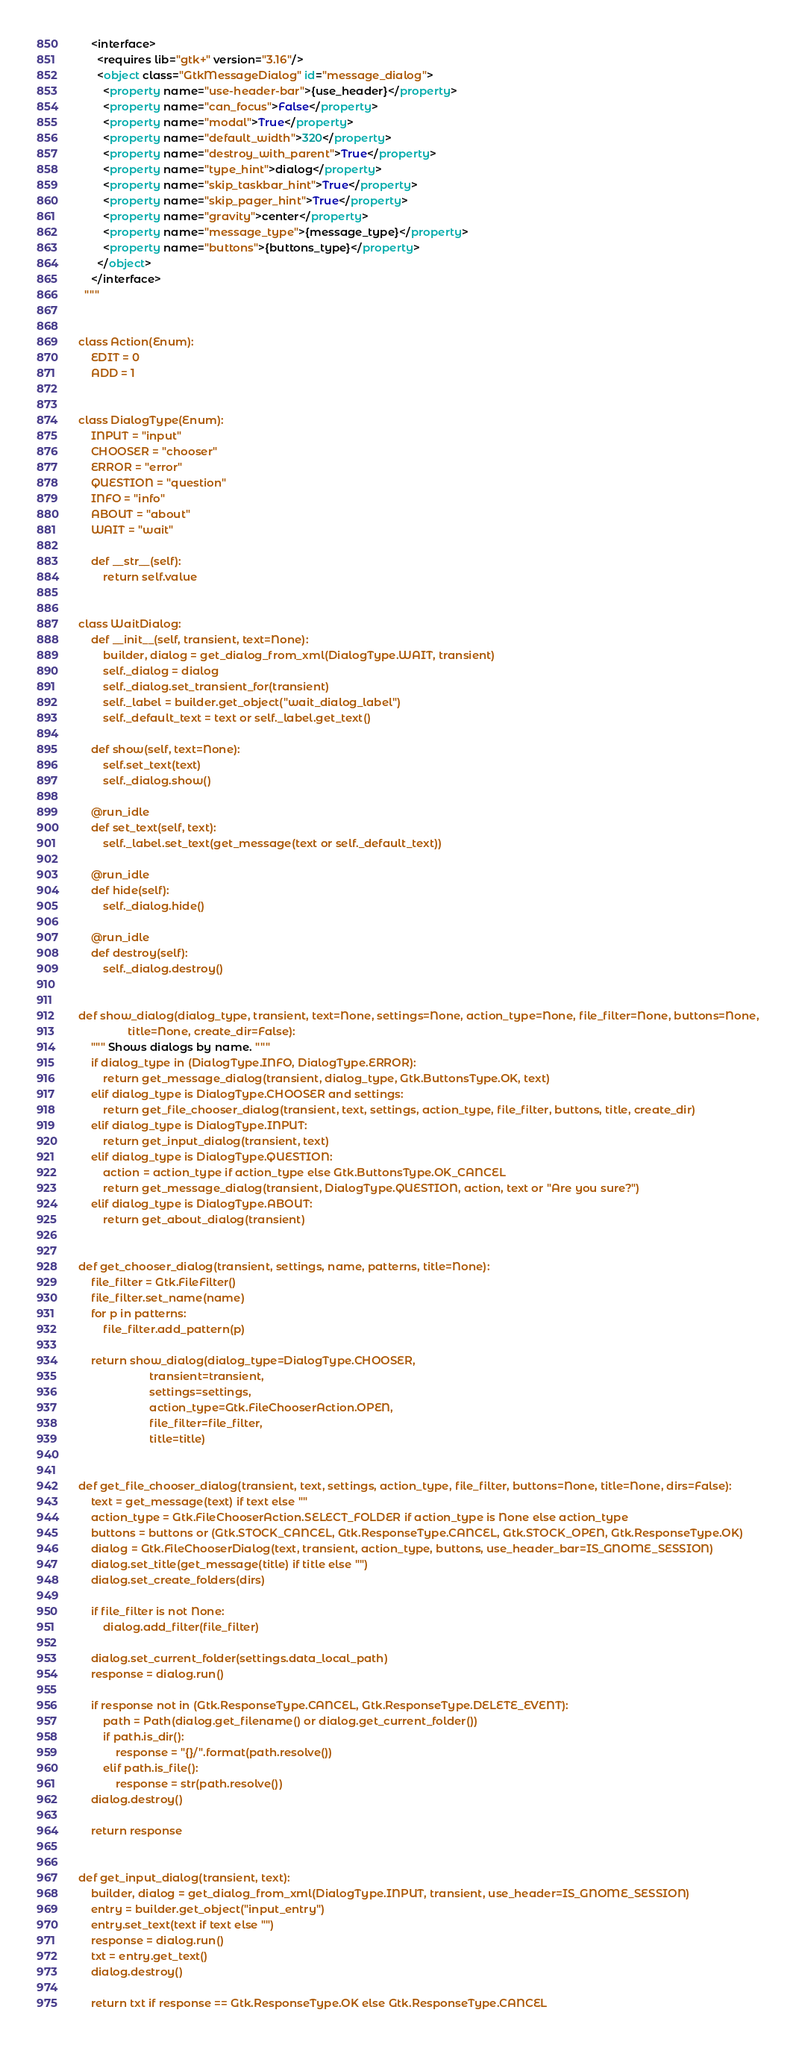Convert code to text. <code><loc_0><loc_0><loc_500><loc_500><_Python_>    <interface>
      <requires lib="gtk+" version="3.16"/>
      <object class="GtkMessageDialog" id="message_dialog">
        <property name="use-header-bar">{use_header}</property>
        <property name="can_focus">False</property>
        <property name="modal">True</property>
        <property name="default_width">320</property>
        <property name="destroy_with_parent">True</property>
        <property name="type_hint">dialog</property>
        <property name="skip_taskbar_hint">True</property>
        <property name="skip_pager_hint">True</property>
        <property name="gravity">center</property>
        <property name="message_type">{message_type}</property>
        <property name="buttons">{buttons_type}</property>
      </object>
    </interface>
  """


class Action(Enum):
    EDIT = 0
    ADD = 1


class DialogType(Enum):
    INPUT = "input"
    CHOOSER = "chooser"
    ERROR = "error"
    QUESTION = "question"
    INFO = "info"
    ABOUT = "about"
    WAIT = "wait"

    def __str__(self):
        return self.value


class WaitDialog:
    def __init__(self, transient, text=None):
        builder, dialog = get_dialog_from_xml(DialogType.WAIT, transient)
        self._dialog = dialog
        self._dialog.set_transient_for(transient)
        self._label = builder.get_object("wait_dialog_label")
        self._default_text = text or self._label.get_text()

    def show(self, text=None):
        self.set_text(text)
        self._dialog.show()

    @run_idle
    def set_text(self, text):
        self._label.set_text(get_message(text or self._default_text))

    @run_idle
    def hide(self):
        self._dialog.hide()

    @run_idle
    def destroy(self):
        self._dialog.destroy()


def show_dialog(dialog_type, transient, text=None, settings=None, action_type=None, file_filter=None, buttons=None,
                title=None, create_dir=False):
    """ Shows dialogs by name. """
    if dialog_type in (DialogType.INFO, DialogType.ERROR):
        return get_message_dialog(transient, dialog_type, Gtk.ButtonsType.OK, text)
    elif dialog_type is DialogType.CHOOSER and settings:
        return get_file_chooser_dialog(transient, text, settings, action_type, file_filter, buttons, title, create_dir)
    elif dialog_type is DialogType.INPUT:
        return get_input_dialog(transient, text)
    elif dialog_type is DialogType.QUESTION:
        action = action_type if action_type else Gtk.ButtonsType.OK_CANCEL
        return get_message_dialog(transient, DialogType.QUESTION, action, text or "Are you sure?")
    elif dialog_type is DialogType.ABOUT:
        return get_about_dialog(transient)


def get_chooser_dialog(transient, settings, name, patterns, title=None):
    file_filter = Gtk.FileFilter()
    file_filter.set_name(name)
    for p in patterns:
        file_filter.add_pattern(p)

    return show_dialog(dialog_type=DialogType.CHOOSER,
                       transient=transient,
                       settings=settings,
                       action_type=Gtk.FileChooserAction.OPEN,
                       file_filter=file_filter,
                       title=title)


def get_file_chooser_dialog(transient, text, settings, action_type, file_filter, buttons=None, title=None, dirs=False):
    text = get_message(text) if text else ""
    action_type = Gtk.FileChooserAction.SELECT_FOLDER if action_type is None else action_type
    buttons = buttons or (Gtk.STOCK_CANCEL, Gtk.ResponseType.CANCEL, Gtk.STOCK_OPEN, Gtk.ResponseType.OK)
    dialog = Gtk.FileChooserDialog(text, transient, action_type, buttons, use_header_bar=IS_GNOME_SESSION)
    dialog.set_title(get_message(title) if title else "")
    dialog.set_create_folders(dirs)

    if file_filter is not None:
        dialog.add_filter(file_filter)

    dialog.set_current_folder(settings.data_local_path)
    response = dialog.run()

    if response not in (Gtk.ResponseType.CANCEL, Gtk.ResponseType.DELETE_EVENT):
        path = Path(dialog.get_filename() or dialog.get_current_folder())
        if path.is_dir():
            response = "{}/".format(path.resolve())
        elif path.is_file():
            response = str(path.resolve())
    dialog.destroy()

    return response


def get_input_dialog(transient, text):
    builder, dialog = get_dialog_from_xml(DialogType.INPUT, transient, use_header=IS_GNOME_SESSION)
    entry = builder.get_object("input_entry")
    entry.set_text(text if text else "")
    response = dialog.run()
    txt = entry.get_text()
    dialog.destroy()

    return txt if response == Gtk.ResponseType.OK else Gtk.ResponseType.CANCEL

</code> 